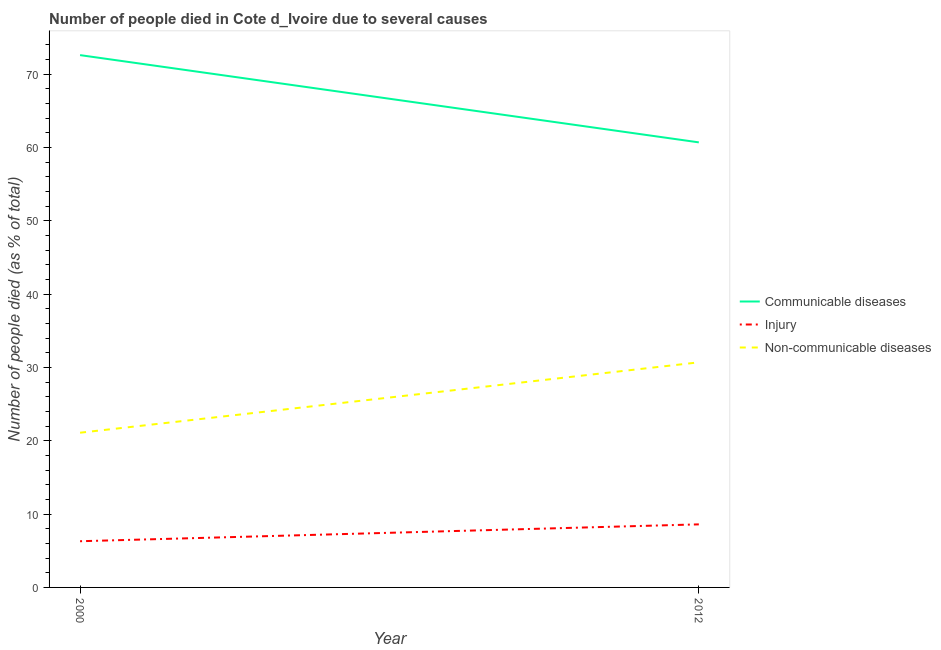What is the number of people who died of communicable diseases in 2000?
Make the answer very short. 72.6. Across all years, what is the maximum number of people who dies of non-communicable diseases?
Make the answer very short. 30.7. Across all years, what is the minimum number of people who died of communicable diseases?
Make the answer very short. 60.7. In which year was the number of people who died of communicable diseases maximum?
Make the answer very short. 2000. What is the total number of people who dies of non-communicable diseases in the graph?
Offer a terse response. 51.8. What is the difference between the number of people who dies of non-communicable diseases in 2000 and that in 2012?
Your response must be concise. -9.6. What is the difference between the number of people who died of communicable diseases in 2012 and the number of people who dies of non-communicable diseases in 2000?
Ensure brevity in your answer.  39.6. What is the average number of people who died of injury per year?
Your answer should be compact. 7.45. In the year 2000, what is the difference between the number of people who dies of non-communicable diseases and number of people who died of injury?
Keep it short and to the point. 14.8. In how many years, is the number of people who died of injury greater than 62 %?
Your answer should be very brief. 0. What is the ratio of the number of people who died of injury in 2000 to that in 2012?
Give a very brief answer. 0.73. Is the number of people who died of communicable diseases in 2000 less than that in 2012?
Make the answer very short. No. In how many years, is the number of people who dies of non-communicable diseases greater than the average number of people who dies of non-communicable diseases taken over all years?
Offer a terse response. 1. Does the number of people who died of communicable diseases monotonically increase over the years?
Offer a very short reply. No. Is the number of people who died of injury strictly greater than the number of people who dies of non-communicable diseases over the years?
Provide a short and direct response. No. What is the difference between two consecutive major ticks on the Y-axis?
Your answer should be very brief. 10. Are the values on the major ticks of Y-axis written in scientific E-notation?
Offer a terse response. No. How many legend labels are there?
Your answer should be compact. 3. How are the legend labels stacked?
Keep it short and to the point. Vertical. What is the title of the graph?
Give a very brief answer. Number of people died in Cote d_Ivoire due to several causes. Does "Fuel" appear as one of the legend labels in the graph?
Ensure brevity in your answer.  No. What is the label or title of the Y-axis?
Provide a short and direct response. Number of people died (as % of total). What is the Number of people died (as % of total) of Communicable diseases in 2000?
Make the answer very short. 72.6. What is the Number of people died (as % of total) of Non-communicable diseases in 2000?
Make the answer very short. 21.1. What is the Number of people died (as % of total) in Communicable diseases in 2012?
Your answer should be compact. 60.7. What is the Number of people died (as % of total) of Injury in 2012?
Your answer should be compact. 8.6. What is the Number of people died (as % of total) of Non-communicable diseases in 2012?
Offer a terse response. 30.7. Across all years, what is the maximum Number of people died (as % of total) in Communicable diseases?
Give a very brief answer. 72.6. Across all years, what is the maximum Number of people died (as % of total) in Non-communicable diseases?
Make the answer very short. 30.7. Across all years, what is the minimum Number of people died (as % of total) of Communicable diseases?
Make the answer very short. 60.7. Across all years, what is the minimum Number of people died (as % of total) in Non-communicable diseases?
Your answer should be very brief. 21.1. What is the total Number of people died (as % of total) of Communicable diseases in the graph?
Offer a terse response. 133.3. What is the total Number of people died (as % of total) of Non-communicable diseases in the graph?
Provide a succinct answer. 51.8. What is the difference between the Number of people died (as % of total) of Non-communicable diseases in 2000 and that in 2012?
Offer a terse response. -9.6. What is the difference between the Number of people died (as % of total) in Communicable diseases in 2000 and the Number of people died (as % of total) in Non-communicable diseases in 2012?
Your response must be concise. 41.9. What is the difference between the Number of people died (as % of total) of Injury in 2000 and the Number of people died (as % of total) of Non-communicable diseases in 2012?
Offer a terse response. -24.4. What is the average Number of people died (as % of total) in Communicable diseases per year?
Offer a terse response. 66.65. What is the average Number of people died (as % of total) of Injury per year?
Give a very brief answer. 7.45. What is the average Number of people died (as % of total) of Non-communicable diseases per year?
Keep it short and to the point. 25.9. In the year 2000, what is the difference between the Number of people died (as % of total) in Communicable diseases and Number of people died (as % of total) in Injury?
Keep it short and to the point. 66.3. In the year 2000, what is the difference between the Number of people died (as % of total) in Communicable diseases and Number of people died (as % of total) in Non-communicable diseases?
Provide a succinct answer. 51.5. In the year 2000, what is the difference between the Number of people died (as % of total) in Injury and Number of people died (as % of total) in Non-communicable diseases?
Offer a very short reply. -14.8. In the year 2012, what is the difference between the Number of people died (as % of total) in Communicable diseases and Number of people died (as % of total) in Injury?
Provide a short and direct response. 52.1. In the year 2012, what is the difference between the Number of people died (as % of total) of Injury and Number of people died (as % of total) of Non-communicable diseases?
Make the answer very short. -22.1. What is the ratio of the Number of people died (as % of total) of Communicable diseases in 2000 to that in 2012?
Your answer should be very brief. 1.2. What is the ratio of the Number of people died (as % of total) in Injury in 2000 to that in 2012?
Provide a short and direct response. 0.73. What is the ratio of the Number of people died (as % of total) in Non-communicable diseases in 2000 to that in 2012?
Provide a succinct answer. 0.69. What is the difference between the highest and the second highest Number of people died (as % of total) of Injury?
Ensure brevity in your answer.  2.3. What is the difference between the highest and the lowest Number of people died (as % of total) of Non-communicable diseases?
Ensure brevity in your answer.  9.6. 